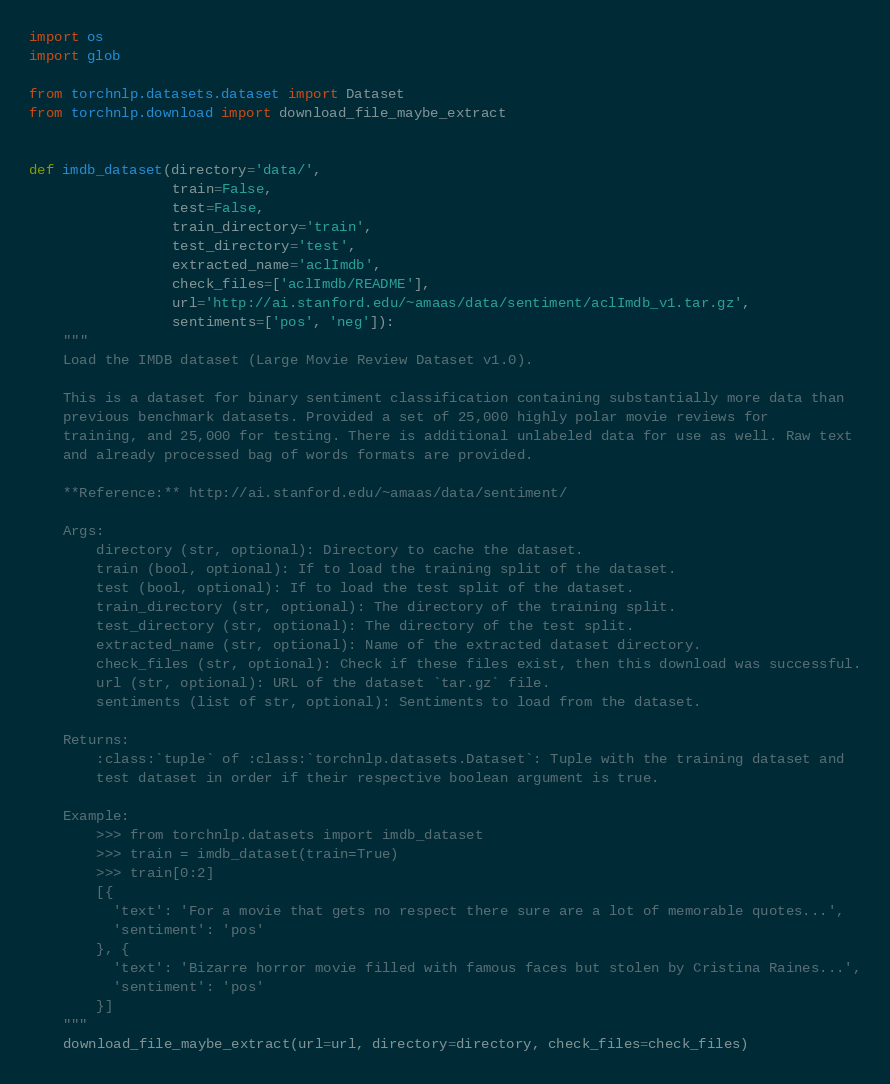<code> <loc_0><loc_0><loc_500><loc_500><_Python_>import os
import glob

from torchnlp.datasets.dataset import Dataset
from torchnlp.download import download_file_maybe_extract


def imdb_dataset(directory='data/',
                 train=False,
                 test=False,
                 train_directory='train',
                 test_directory='test',
                 extracted_name='aclImdb',
                 check_files=['aclImdb/README'],
                 url='http://ai.stanford.edu/~amaas/data/sentiment/aclImdb_v1.tar.gz',
                 sentiments=['pos', 'neg']):
    """
    Load the IMDB dataset (Large Movie Review Dataset v1.0).

    This is a dataset for binary sentiment classification containing substantially more data than
    previous benchmark datasets. Provided a set of 25,000 highly polar movie reviews for
    training, and 25,000 for testing. There is additional unlabeled data for use as well. Raw text
    and already processed bag of words formats are provided.

    **Reference:** http://ai.stanford.edu/~amaas/data/sentiment/

    Args:
        directory (str, optional): Directory to cache the dataset.
        train (bool, optional): If to load the training split of the dataset.
        test (bool, optional): If to load the test split of the dataset.
        train_directory (str, optional): The directory of the training split.
        test_directory (str, optional): The directory of the test split.
        extracted_name (str, optional): Name of the extracted dataset directory.
        check_files (str, optional): Check if these files exist, then this download was successful.
        url (str, optional): URL of the dataset `tar.gz` file.
        sentiments (list of str, optional): Sentiments to load from the dataset.

    Returns:
        :class:`tuple` of :class:`torchnlp.datasets.Dataset`: Tuple with the training dataset and
        test dataset in order if their respective boolean argument is true.

    Example:
        >>> from torchnlp.datasets import imdb_dataset
        >>> train = imdb_dataset(train=True)
        >>> train[0:2]
        [{
          'text': 'For a movie that gets no respect there sure are a lot of memorable quotes...',
          'sentiment': 'pos'
        }, {
          'text': 'Bizarre horror movie filled with famous faces but stolen by Cristina Raines...',
          'sentiment': 'pos'
        }]
    """
    download_file_maybe_extract(url=url, directory=directory, check_files=check_files)
</code> 